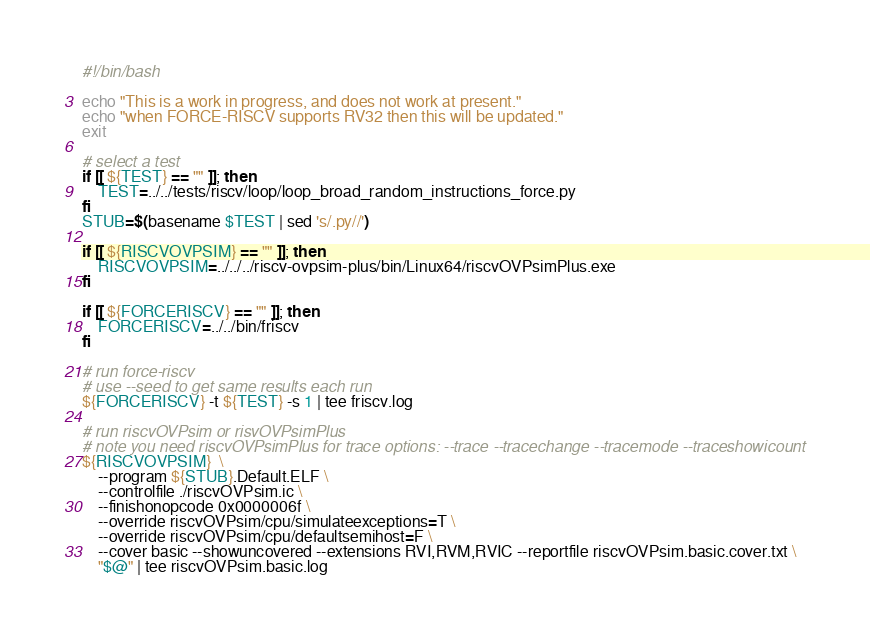<code> <loc_0><loc_0><loc_500><loc_500><_Bash_>#!/bin/bash

echo "This is a work in progress, and does not work at present."
echo "when FORCE-RISCV supports RV32 then this will be updated."
exit

# select a test
if [[ ${TEST} == "" ]]; then
    TEST=../../tests/riscv/loop/loop_broad_random_instructions_force.py
fi
STUB=$(basename $TEST | sed 's/.py//')

if [[ ${RISCVOVPSIM} == "" ]]; then
    RISCVOVPSIM=../../../riscv-ovpsim-plus/bin/Linux64/riscvOVPsimPlus.exe
fi

if [[ ${FORCERISCV} == "" ]]; then
    FORCERISCV=../../bin/friscv
fi

# run force-riscv
# use --seed to get same results each run
${FORCERISCV} -t ${TEST} -s 1 | tee friscv.log

# run riscvOVPsim or risvOVPsimPlus
# note you need riscvOVPsimPlus for trace options: --trace --tracechange --tracemode --traceshowicount
${RISCVOVPSIM}  \
    --program ${STUB}.Default.ELF \
    --controlfile ./riscvOVPsim.ic \
    --finishonopcode 0x0000006f \
    --override riscvOVPsim/cpu/simulateexceptions=T \
    --override riscvOVPsim/cpu/defaultsemihost=F \
    --cover basic --showuncovered --extensions RVI,RVM,RVIC --reportfile riscvOVPsim.basic.cover.txt \
    "$@" | tee riscvOVPsim.basic.log
</code> 